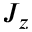Convert formula to latex. <formula><loc_0><loc_0><loc_500><loc_500>J _ { z }</formula> 